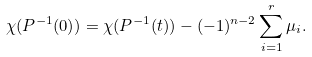Convert formula to latex. <formula><loc_0><loc_0><loc_500><loc_500>\chi ( P ^ { - 1 } ( 0 ) ) = \chi ( P ^ { - 1 } ( t ) ) - ( - 1 ) ^ { n - 2 } \sum _ { i = 1 } ^ { r } \mu _ { i } .</formula> 